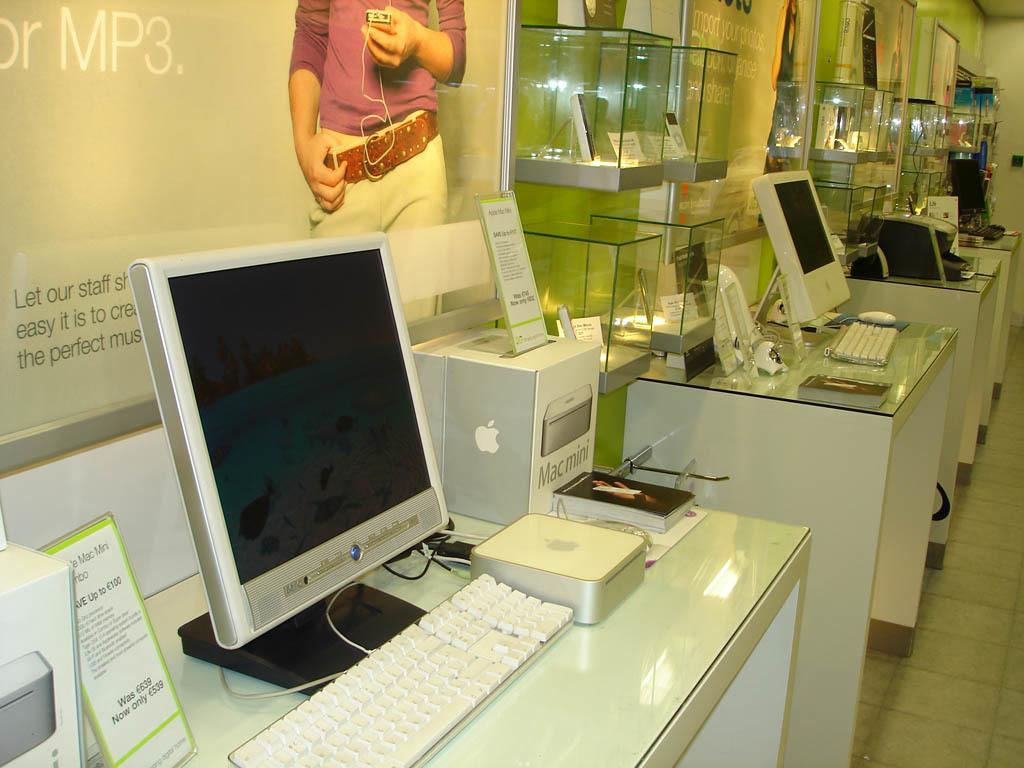<image>
Relay a brief, clear account of the picture shown. A sign over a computer says MP3 on it. 